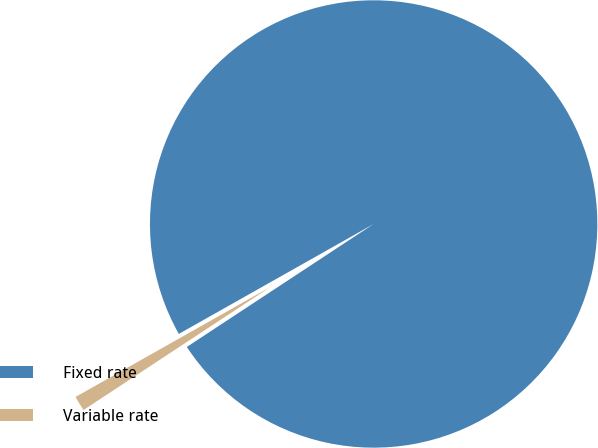<chart> <loc_0><loc_0><loc_500><loc_500><pie_chart><fcel>Fixed rate<fcel>Variable rate<nl><fcel>98.91%<fcel>1.09%<nl></chart> 